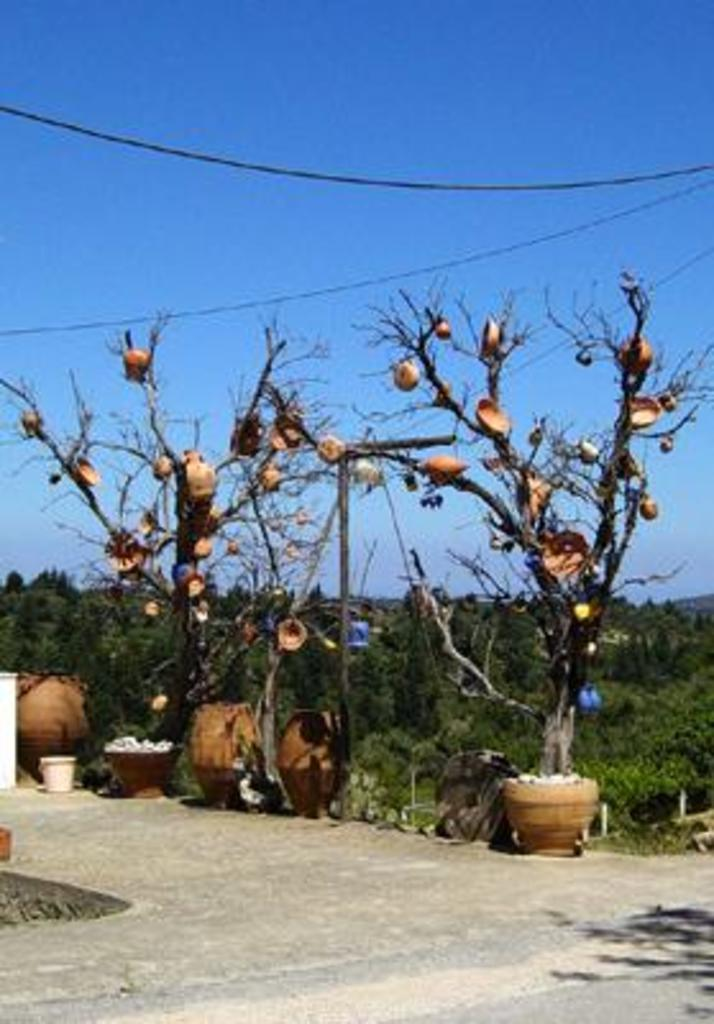What is located in the middle of the image? There are trees in the middle of the image. What is visible at the top of the image? The sky is visible at the top of the image. What objects can be seen at the bottom of the image? There are pots at the bottom of the image. Where is the quiver located in the image? There is no quiver present in the image. What type of room is depicted in the image? The image does not depict a room; it features trees, sky, and pots. 